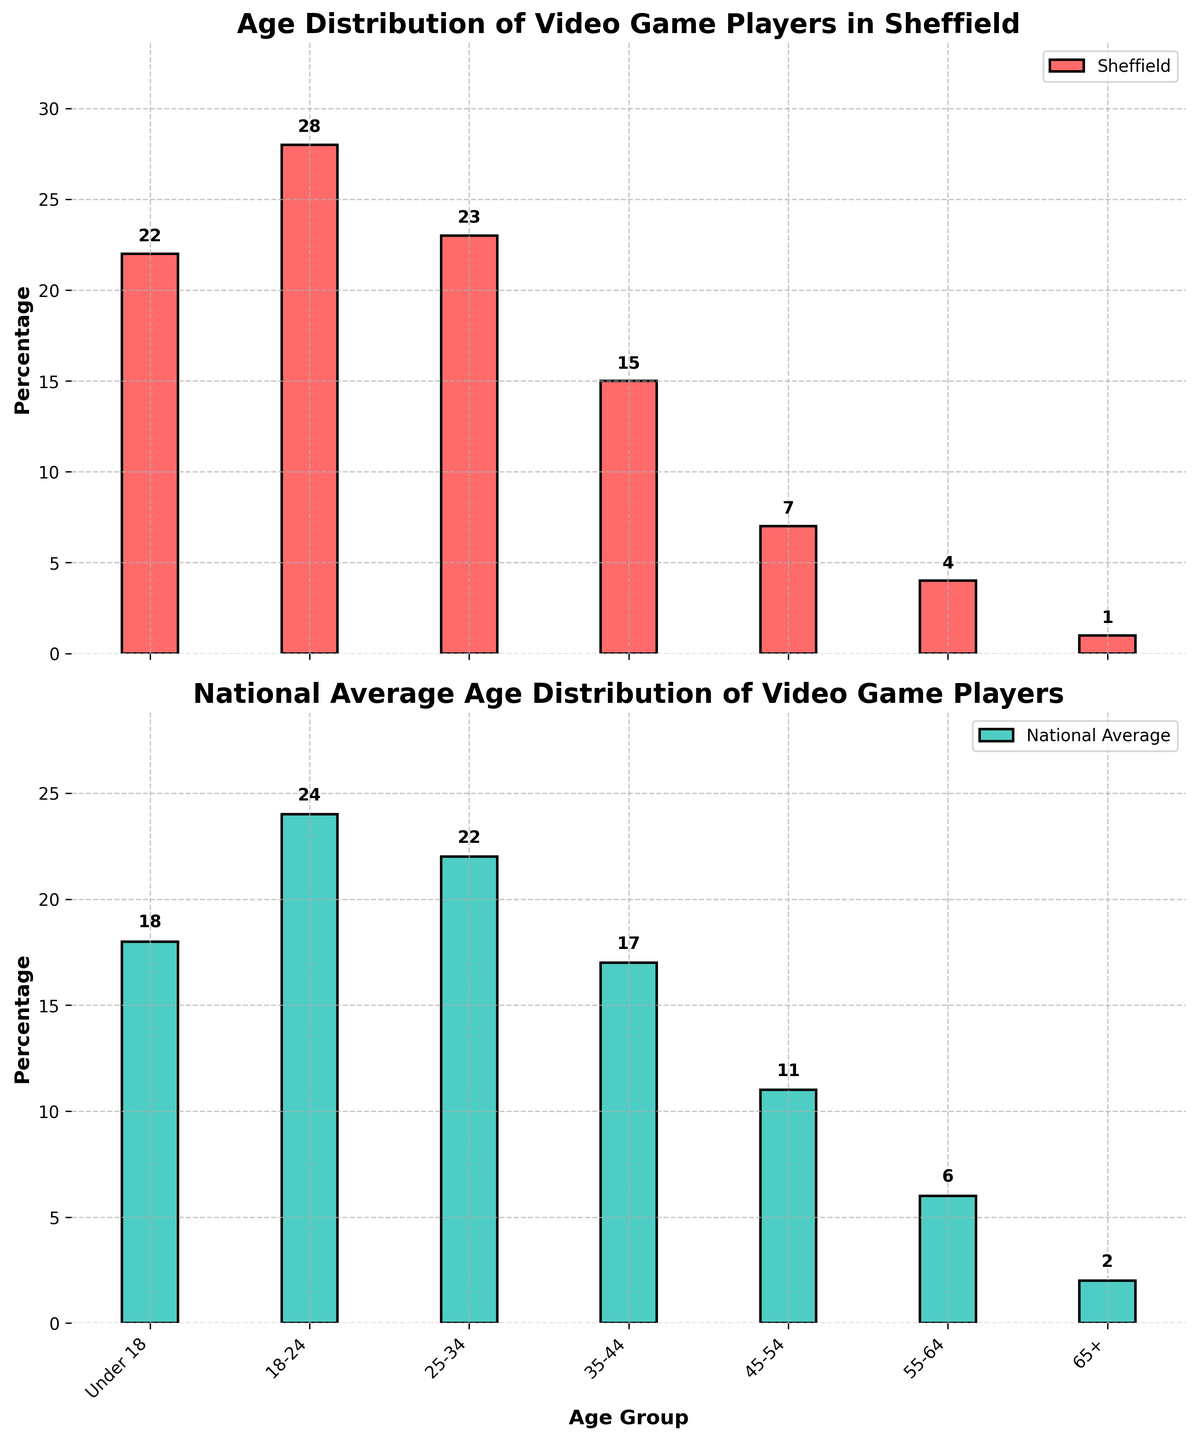What is the percentage of video game players in Sheffield under 18 compared to the national average? From the figure, find the height of the bars for the "Under 18" age group in both the Sheffield and National Average plots. Sheffield has 22%, and the national average has 18%.
Answer: Sheffield: 22%, National: 18% Which age group has the highest percentage of video game players in Sheffield? Look at the figure and identify the age group with the tallest bar in the Sheffield subplot. The "18-24" age group has the tallest bar, representing 28%.
Answer: 18-24 By how much is the percentage of 45-54-year-old video game players in Sheffield lower than the national average? Find the height of the bars for the "45-54" age group in both subplots. Sheffield's bar is at 7%, and the national average bar is at 11%. Subtract Sheffield's value from the national average: 11% - 7% = 4%.
Answer: 4% Which age group shows the closest percentage of video game players between Sheffield and the national average? Compare the heights of the bars for each age group between the two subplots and find the smallest difference. The "25-34" age group has Sheffield at 23% and the national average at 22%, which is a 1% difference.
Answer: 25-34 What is the total combined percentage of video game players in Sheffield for the age groups 18-24 and 25-34? Add the percentages for the "18-24" and "25-34" age groups from the Sheffield subplot. That is 28% (18-24) + 23% (25-34) = 51%.
Answer: 51% What is the difference in the percentage of video game players in the 55-64 age group between Sheffield and the national average? Find the heights of the bars for the "55-64" age group in both subplots. Sheffield's bar is at 4%, and the national average bar is at 6%. Subtract Sheffield's value from the national average: 6% - 4% = 2%.
Answer: 2% Which age group in Sheffield has twice the percentage of video game players compared to the average national percentage for the same group? Compare the percentages for each age group in Sheffield with their national average and see which one is approximately two times greater. The "45-54" group in Sheffield is 7%, while the national average is 11%, which is not twice. No group has exactly twice but the "Under 18" (22% Sheffield vs 18% national) is the closest with approximately 1.22 times.
Answer: None exactly, closest is "Under 18" How does the percentage of video game players aged 65+ in Sheffield compare visually to the same group in the national average? Observe the heights of the bars for the "65+" age group in both subplots. Sheffield's bar is shorter (1%) compared to the national average bar (2%).
Answer: Sheffield: shorter What is the average percentage of video game players across all age groups in Sheffield? Sum the percentages for all age groups in the Sheffield subplot (22 + 28 + 23 + 15 + 7 + 4 + 1 = 100) and divide by the number of age groups (7). The average is 100% / 7 ≈ 14.29%.
Answer: 14.29% 